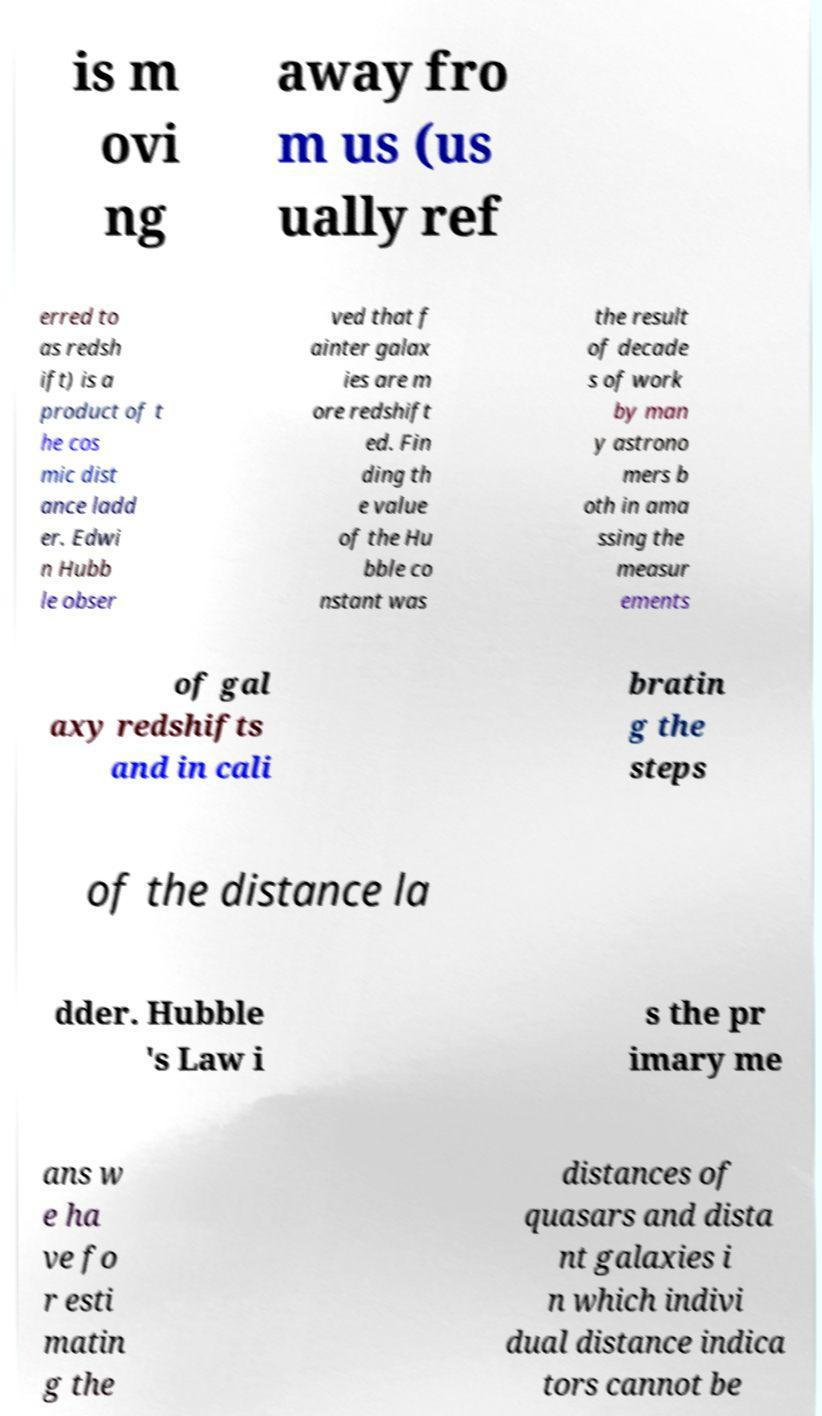Please identify and transcribe the text found in this image. is m ovi ng away fro m us (us ually ref erred to as redsh ift) is a product of t he cos mic dist ance ladd er. Edwi n Hubb le obser ved that f ainter galax ies are m ore redshift ed. Fin ding th e value of the Hu bble co nstant was the result of decade s of work by man y astrono mers b oth in ama ssing the measur ements of gal axy redshifts and in cali bratin g the steps of the distance la dder. Hubble 's Law i s the pr imary me ans w e ha ve fo r esti matin g the distances of quasars and dista nt galaxies i n which indivi dual distance indica tors cannot be 